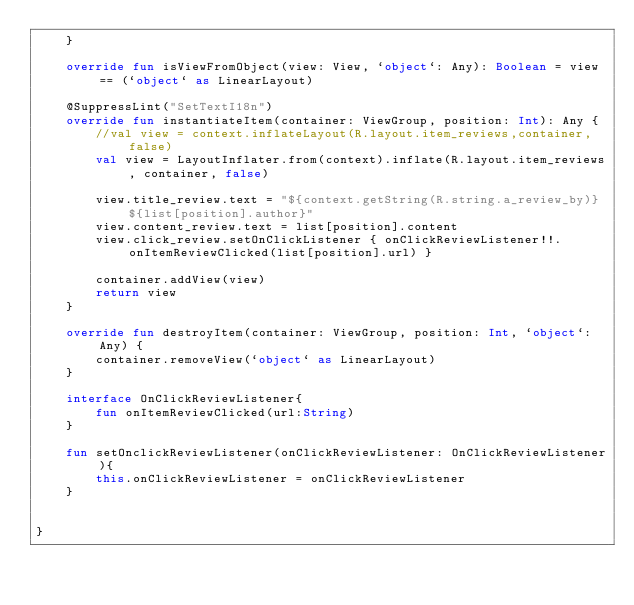Convert code to text. <code><loc_0><loc_0><loc_500><loc_500><_Kotlin_>    }

    override fun isViewFromObject(view: View, `object`: Any): Boolean = view == (`object` as LinearLayout)

    @SuppressLint("SetTextI18n")
    override fun instantiateItem(container: ViewGroup, position: Int): Any {
        //val view = context.inflateLayout(R.layout.item_reviews,container,false)
        val view = LayoutInflater.from(context).inflate(R.layout.item_reviews, container, false)

        view.title_review.text = "${context.getString(R.string.a_review_by)} ${list[position].author}"
        view.content_review.text = list[position].content
        view.click_review.setOnClickListener { onClickReviewListener!!.onItemReviewClicked(list[position].url) }

        container.addView(view)
        return view
    }

    override fun destroyItem(container: ViewGroup, position: Int, `object`: Any) {
        container.removeView(`object` as LinearLayout)
    }

    interface OnClickReviewListener{
        fun onItemReviewClicked(url:String)
    }

    fun setOnclickReviewListener(onClickReviewListener: OnClickReviewListener){
        this.onClickReviewListener = onClickReviewListener
    }


}</code> 